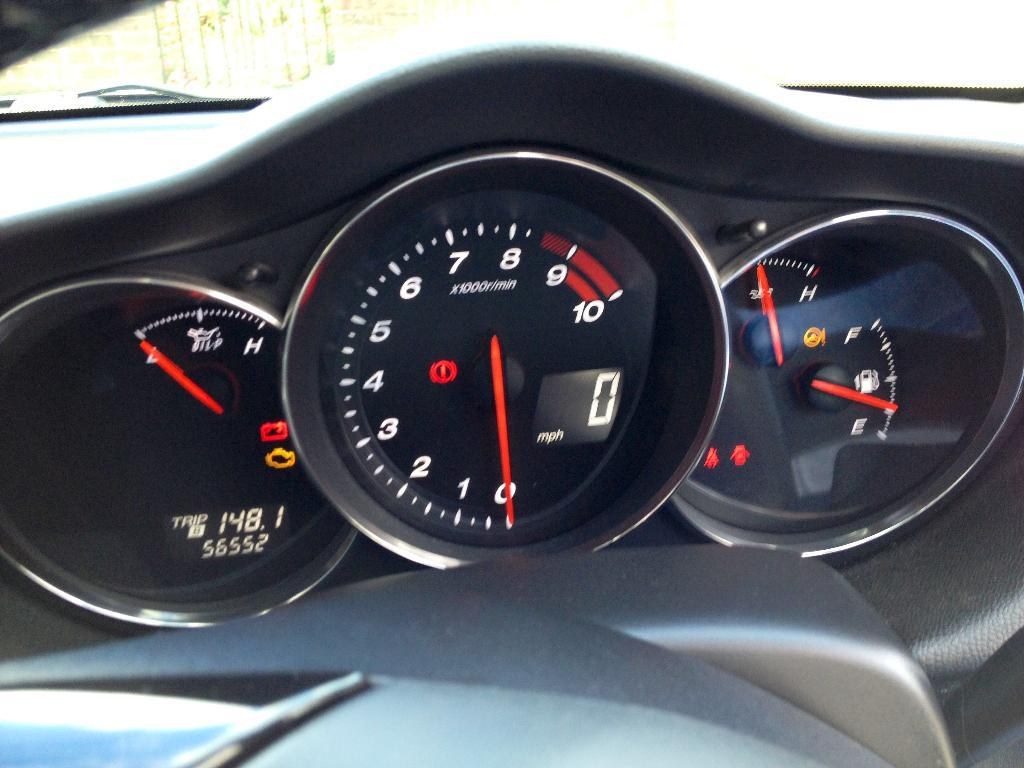What type of environment is depicted in the image? The image is an inside view of a car. What can be seen in the center of the image? There are analog meters in the center of the image. Where is the icicle hanging in the image? There is no icicle present in the image; it is an inside view of a car. What type of fruit is sitting on the throne in the image? There is no fruit or throne present in the image; it is an inside view of a car with analog meters in the center. 